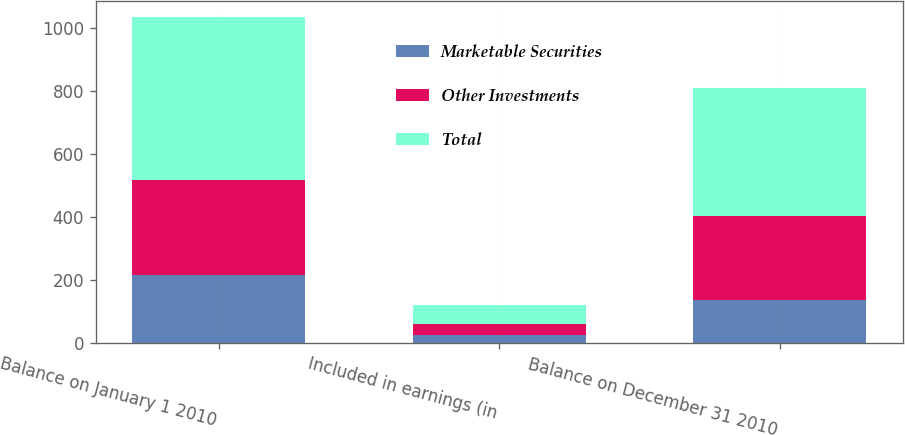Convert chart to OTSL. <chart><loc_0><loc_0><loc_500><loc_500><stacked_bar_chart><ecel><fcel>Balance on January 1 2010<fcel>Included in earnings (in<fcel>Balance on December 31 2010<nl><fcel>Marketable Securities<fcel>216<fcel>27<fcel>138<nl><fcel>Other Investments<fcel>301<fcel>34<fcel>267<nl><fcel>Total<fcel>517<fcel>61<fcel>405<nl></chart> 